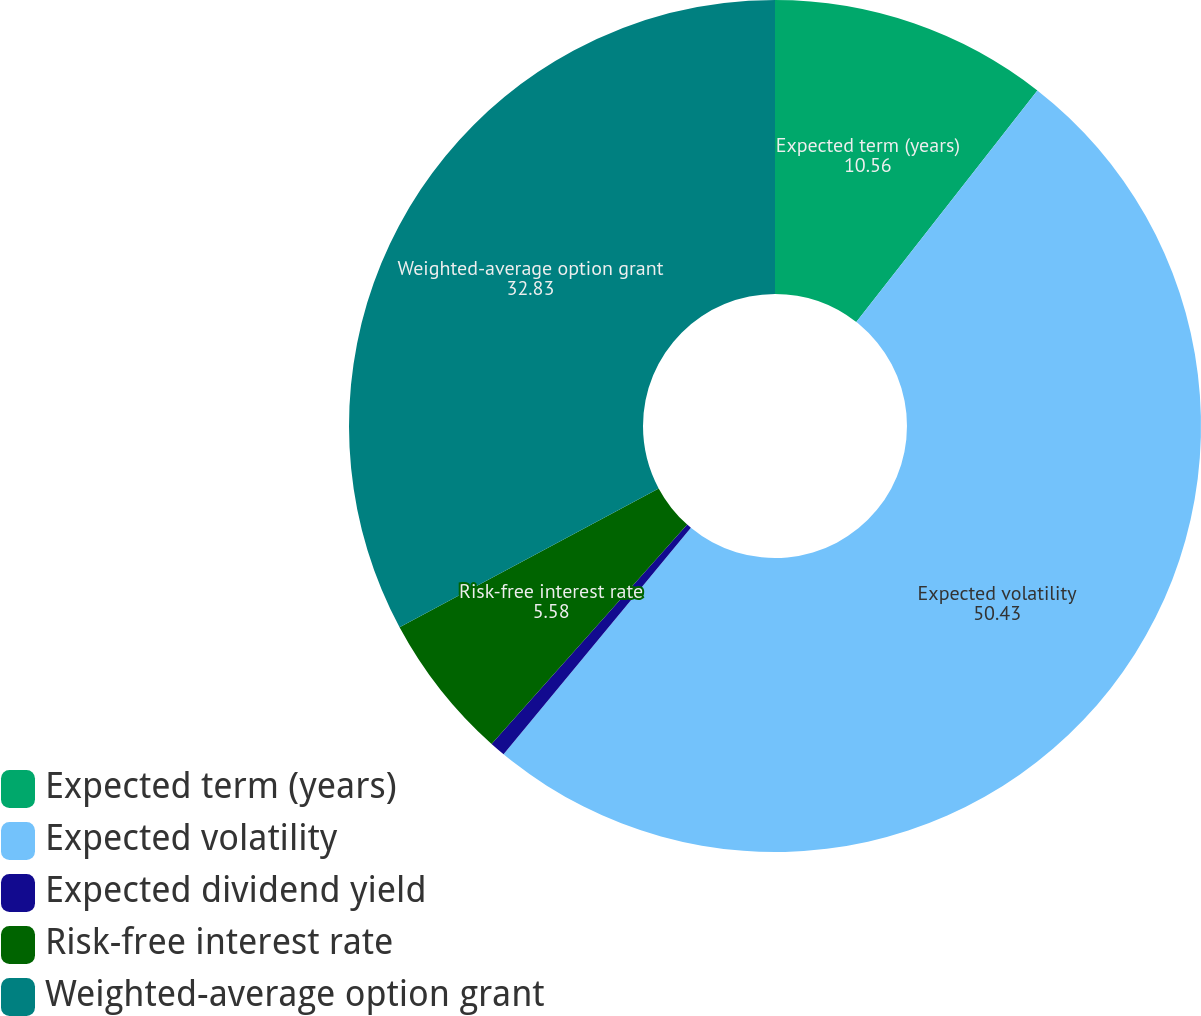<chart> <loc_0><loc_0><loc_500><loc_500><pie_chart><fcel>Expected term (years)<fcel>Expected volatility<fcel>Expected dividend yield<fcel>Risk-free interest rate<fcel>Weighted-average option grant<nl><fcel>10.56%<fcel>50.43%<fcel>0.59%<fcel>5.58%<fcel>32.83%<nl></chart> 